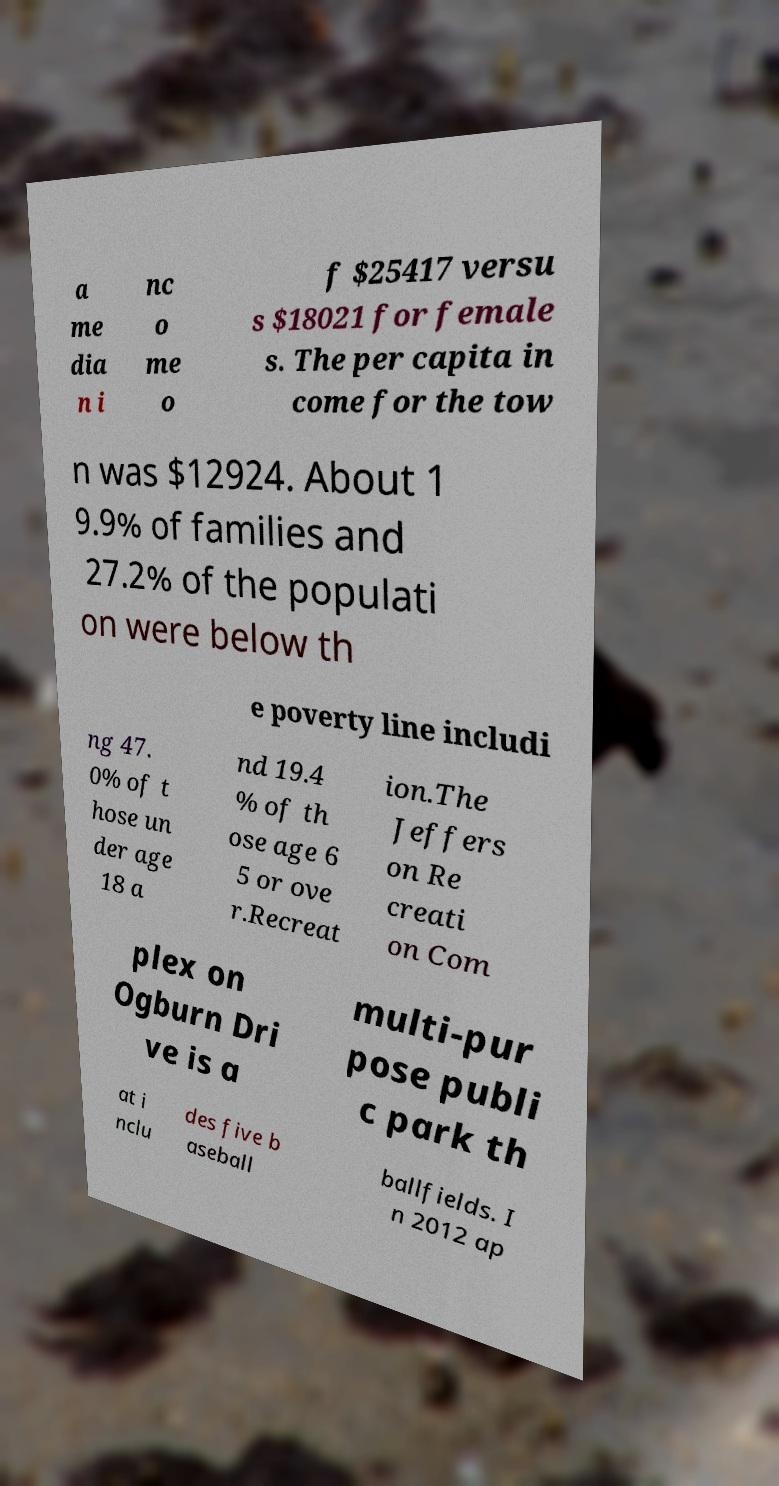Can you accurately transcribe the text from the provided image for me? a me dia n i nc o me o f $25417 versu s $18021 for female s. The per capita in come for the tow n was $12924. About 1 9.9% of families and 27.2% of the populati on were below th e poverty line includi ng 47. 0% of t hose un der age 18 a nd 19.4 % of th ose age 6 5 or ove r.Recreat ion.The Jeffers on Re creati on Com plex on Ogburn Dri ve is a multi-pur pose publi c park th at i nclu des five b aseball ballfields. I n 2012 ap 